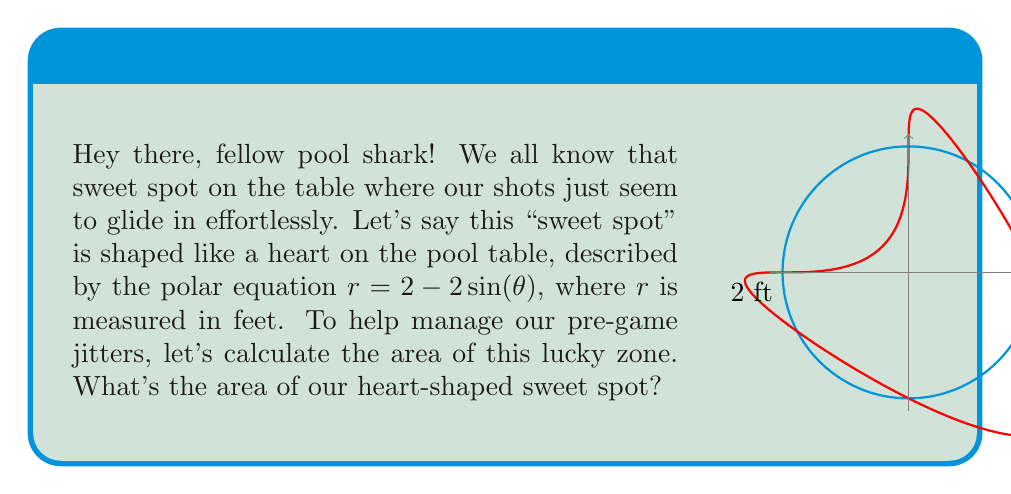What is the answer to this math problem? Alright, buddy, let's break this down step-by-step to keep our nerves in check:

1) The area of a region in polar coordinates is given by the formula:

   $$A = \frac{1}{2} \int_a^b r^2(\theta) d\theta$$

2) Our heart-shaped sweet spot is described by $r = 2 - 2\sin(\theta)$. We need to square this:

   $$r^2 = (2 - 2\sin(\theta))^2 = 4 - 8\sin(\theta) + 4\sin^2(\theta)$$

3) The heart shape completes one full revolution, so we integrate from 0 to $2\pi$:

   $$A = \frac{1}{2} \int_0^{2\pi} (4 - 8\sin(\theta) + 4\sin^2(\theta)) d\theta$$

4) Let's integrate each term:
   
   $$\begin{align*}
   A &= \frac{1}{2} \left[4\theta - 8(-\cos(\theta)) + 4(\frac{\theta}{2} - \frac{\sin(2\theta)}{4})\right]_0^{2\pi} \\
   &= \frac{1}{2} \left[(8\pi - 0) + (0 - 0) + (4\pi - 0)\right] \\
   &= \frac{1}{2} (12\pi) = 6\pi
   \end{align*}$$

5) Therefore, the area of our sweet spot is $6\pi$ square feet.

Remember, calculating this area is just like lining up a perfect shot - take it step by step, and you'll sink it every time!
Answer: $6\pi$ square feet 